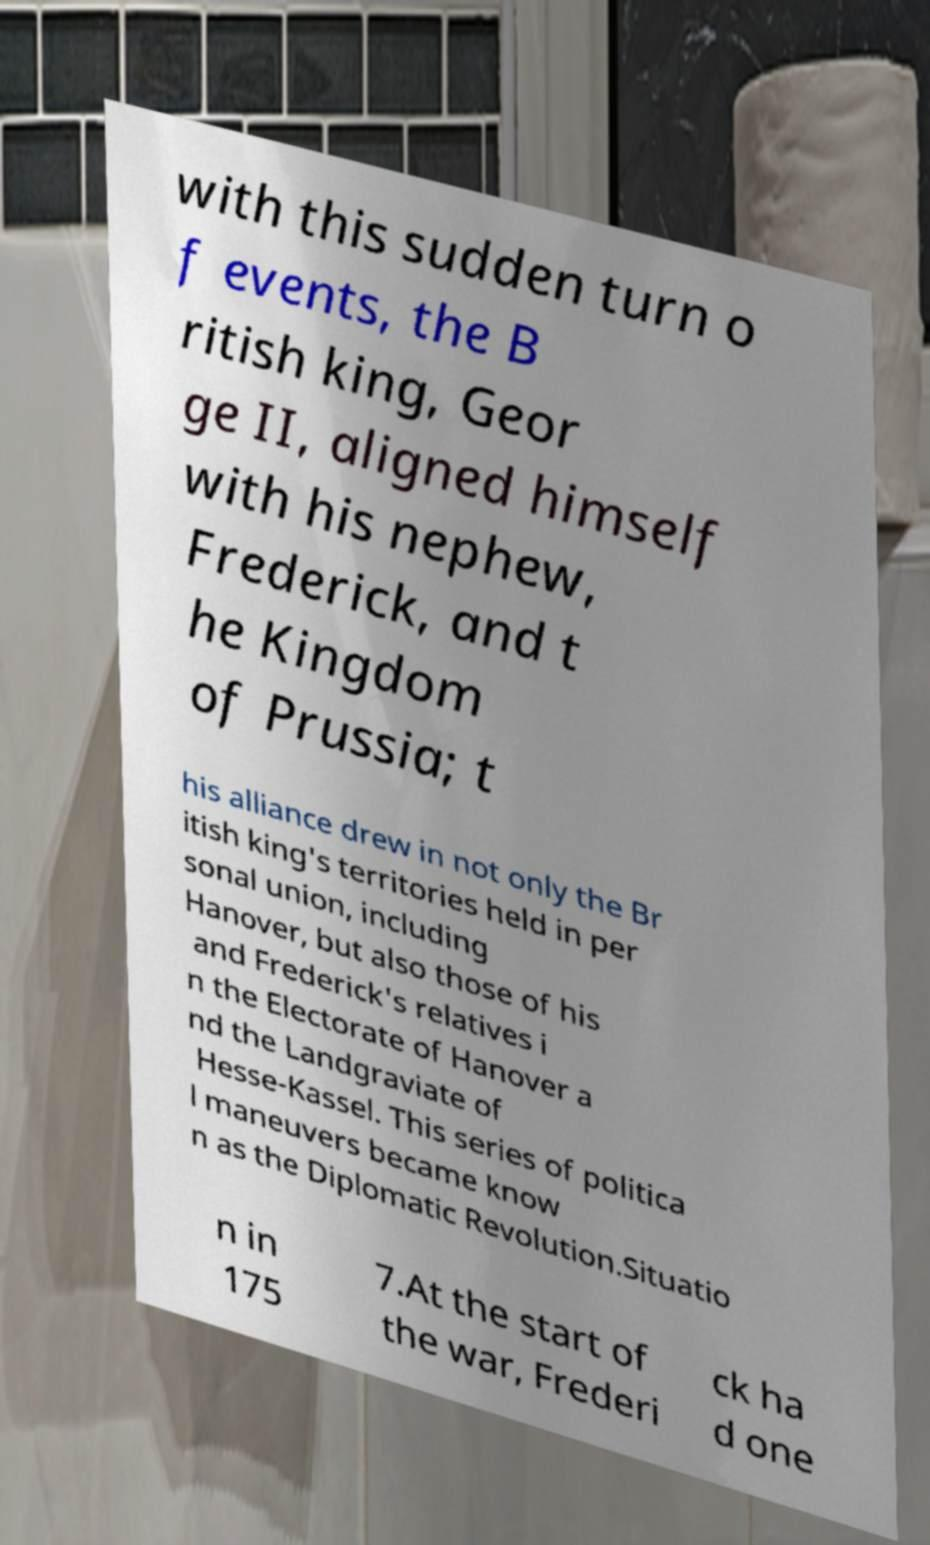For documentation purposes, I need the text within this image transcribed. Could you provide that? with this sudden turn o f events, the B ritish king, Geor ge II, aligned himself with his nephew, Frederick, and t he Kingdom of Prussia; t his alliance drew in not only the Br itish king's territories held in per sonal union, including Hanover, but also those of his and Frederick's relatives i n the Electorate of Hanover a nd the Landgraviate of Hesse-Kassel. This series of politica l maneuvers became know n as the Diplomatic Revolution.Situatio n in 175 7.At the start of the war, Frederi ck ha d one 